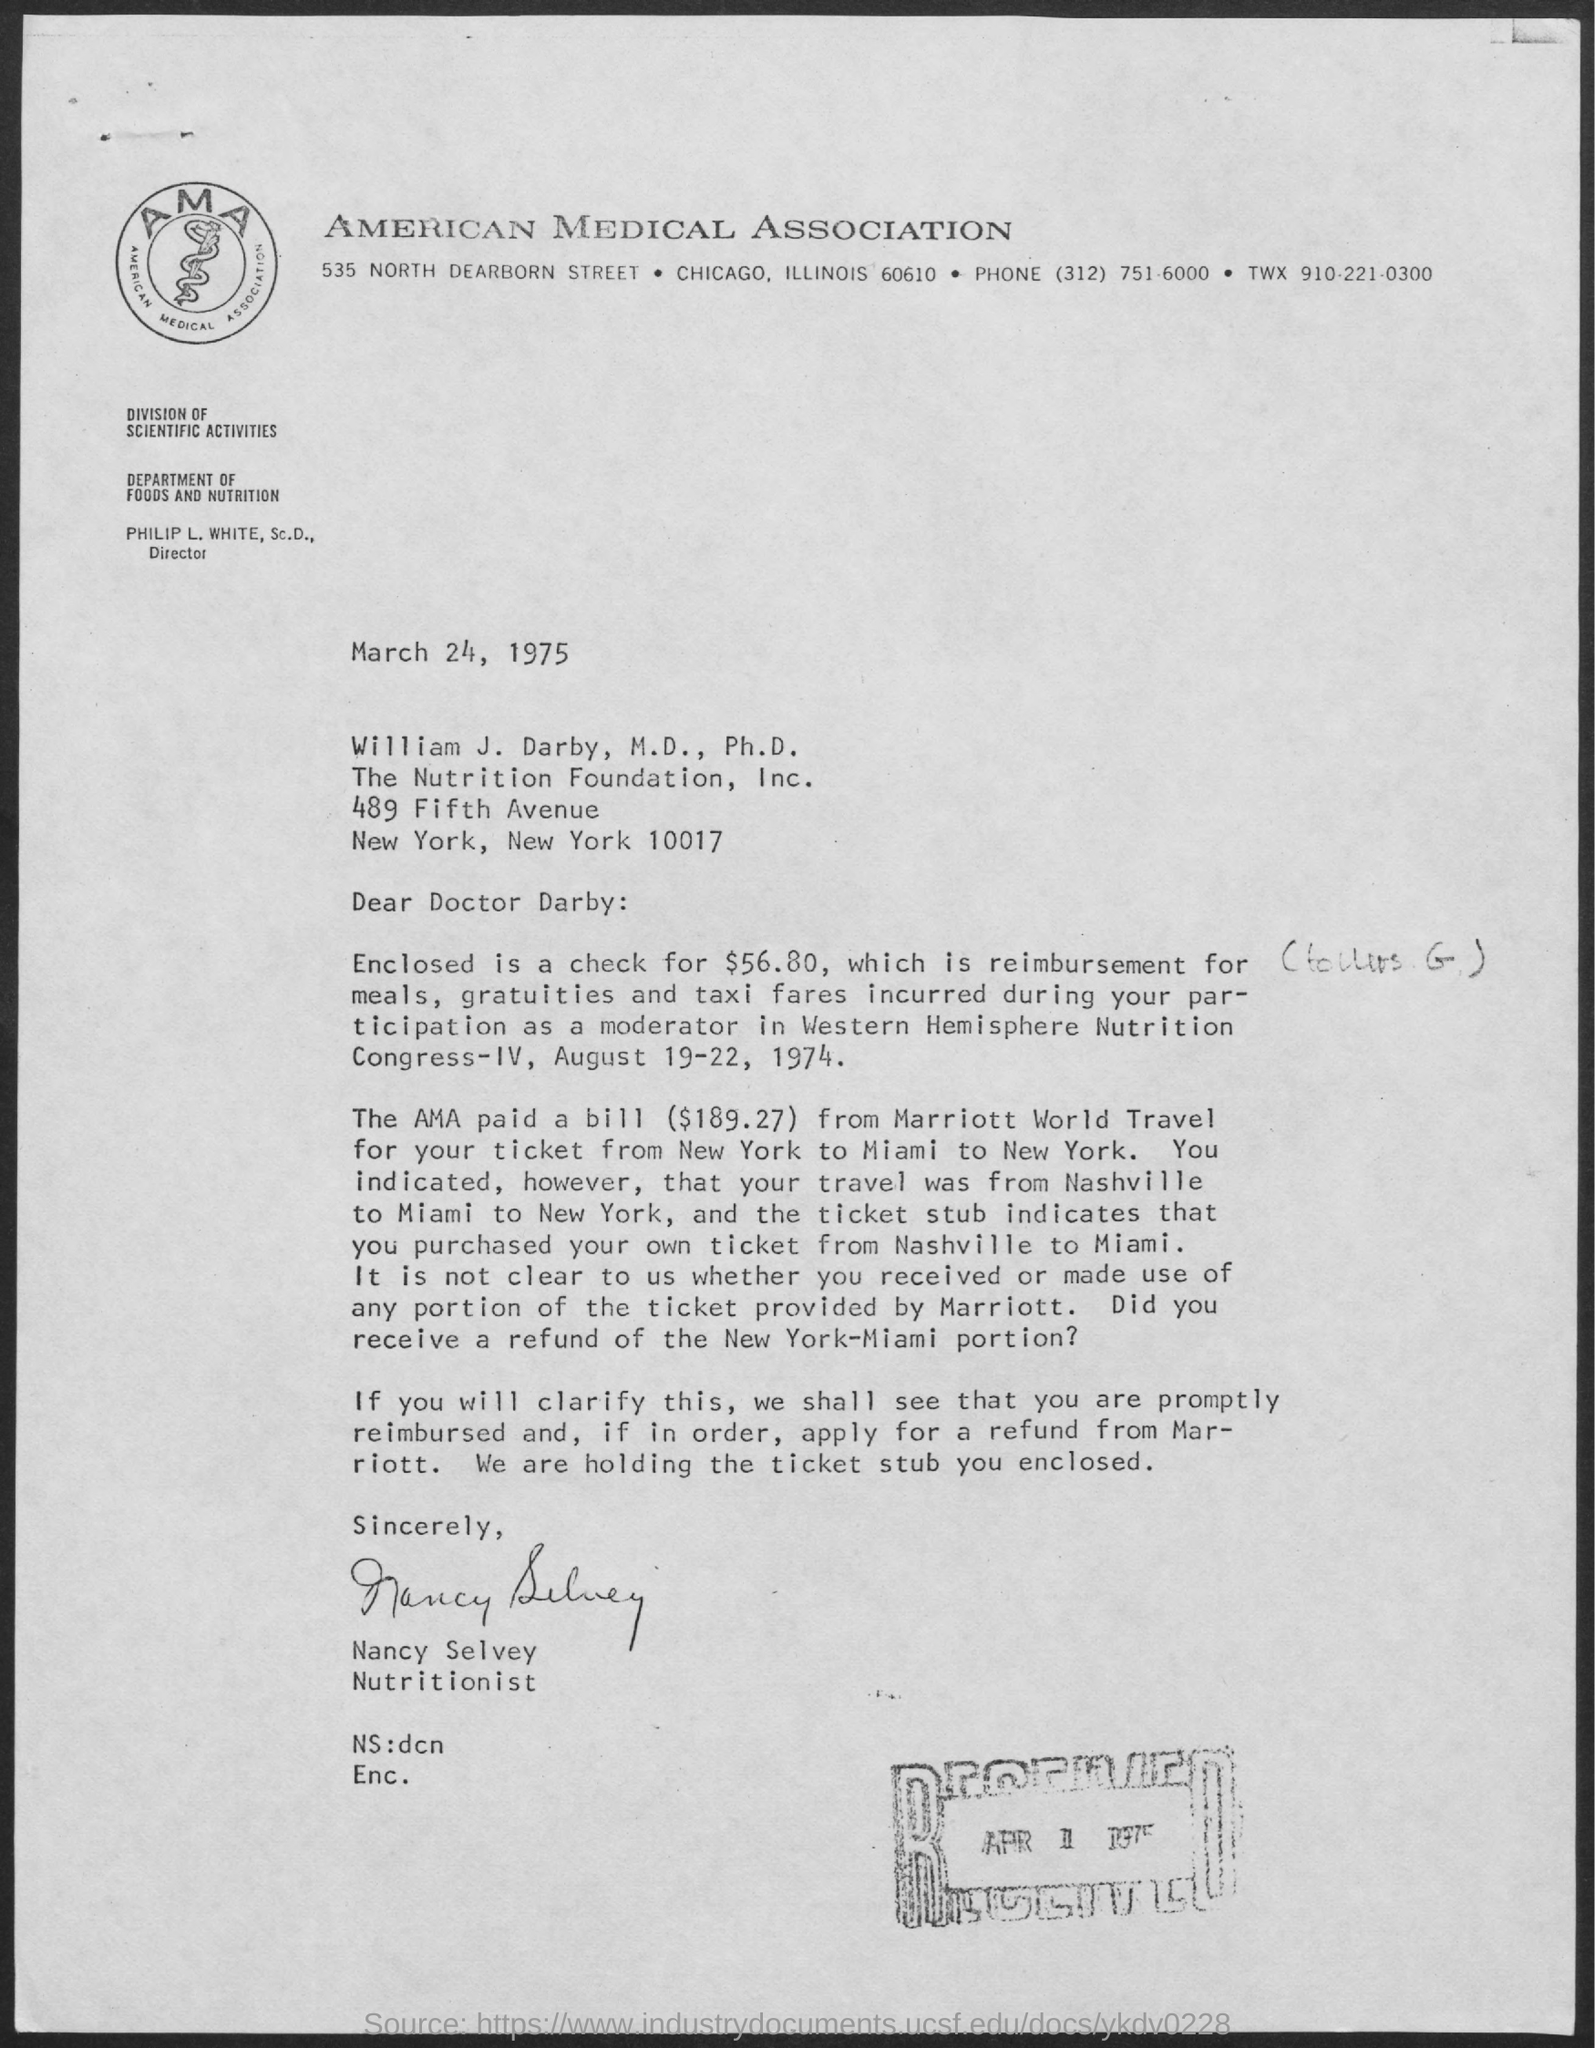Indicate a few pertinent items in this graphic. The date mentioned at the top of the document is March 24, 1975. The title of the document is "American Medical Association. 